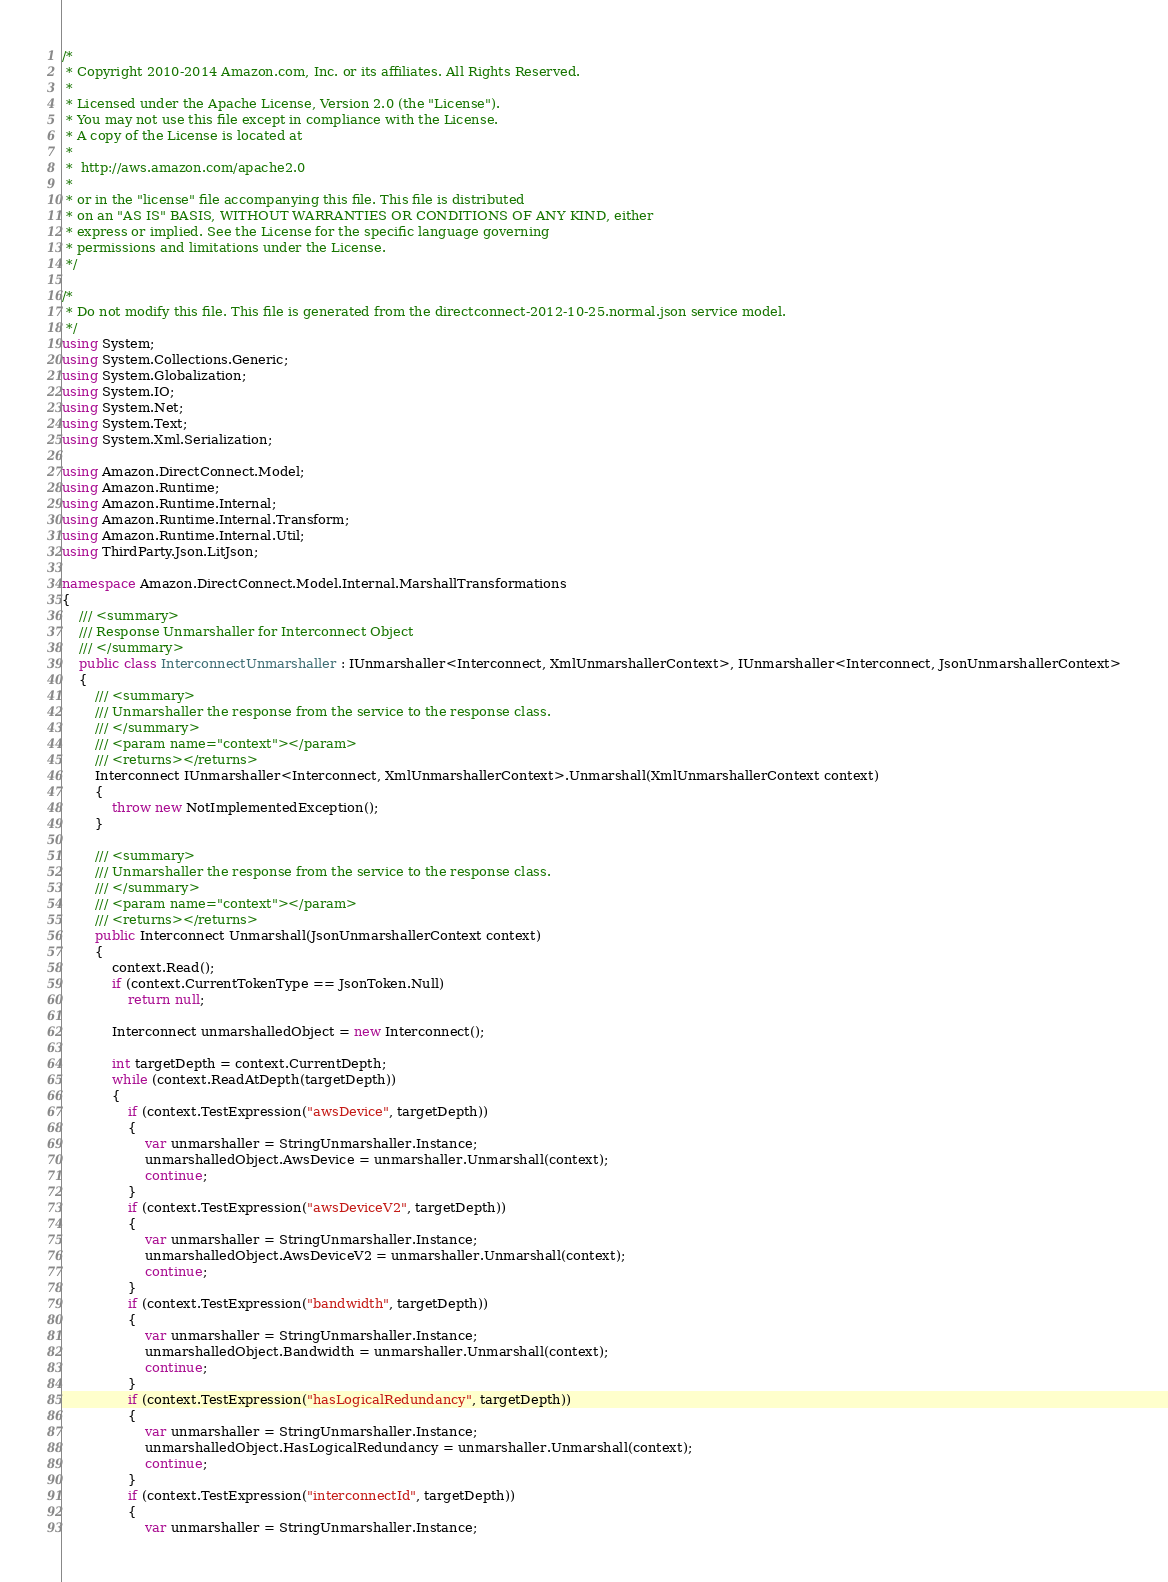Convert code to text. <code><loc_0><loc_0><loc_500><loc_500><_C#_>/*
 * Copyright 2010-2014 Amazon.com, Inc. or its affiliates. All Rights Reserved.
 * 
 * Licensed under the Apache License, Version 2.0 (the "License").
 * You may not use this file except in compliance with the License.
 * A copy of the License is located at
 * 
 *  http://aws.amazon.com/apache2.0
 * 
 * or in the "license" file accompanying this file. This file is distributed
 * on an "AS IS" BASIS, WITHOUT WARRANTIES OR CONDITIONS OF ANY KIND, either
 * express or implied. See the License for the specific language governing
 * permissions and limitations under the License.
 */

/*
 * Do not modify this file. This file is generated from the directconnect-2012-10-25.normal.json service model.
 */
using System;
using System.Collections.Generic;
using System.Globalization;
using System.IO;
using System.Net;
using System.Text;
using System.Xml.Serialization;

using Amazon.DirectConnect.Model;
using Amazon.Runtime;
using Amazon.Runtime.Internal;
using Amazon.Runtime.Internal.Transform;
using Amazon.Runtime.Internal.Util;
using ThirdParty.Json.LitJson;

namespace Amazon.DirectConnect.Model.Internal.MarshallTransformations
{
    /// <summary>
    /// Response Unmarshaller for Interconnect Object
    /// </summary>  
    public class InterconnectUnmarshaller : IUnmarshaller<Interconnect, XmlUnmarshallerContext>, IUnmarshaller<Interconnect, JsonUnmarshallerContext>
    {
        /// <summary>
        /// Unmarshaller the response from the service to the response class.
        /// </summary>  
        /// <param name="context"></param>
        /// <returns></returns>
        Interconnect IUnmarshaller<Interconnect, XmlUnmarshallerContext>.Unmarshall(XmlUnmarshallerContext context)
        {
            throw new NotImplementedException();
        }

        /// <summary>
        /// Unmarshaller the response from the service to the response class.
        /// </summary>  
        /// <param name="context"></param>
        /// <returns></returns>
        public Interconnect Unmarshall(JsonUnmarshallerContext context)
        {
            context.Read();
            if (context.CurrentTokenType == JsonToken.Null) 
                return null;

            Interconnect unmarshalledObject = new Interconnect();
        
            int targetDepth = context.CurrentDepth;
            while (context.ReadAtDepth(targetDepth))
            {
                if (context.TestExpression("awsDevice", targetDepth))
                {
                    var unmarshaller = StringUnmarshaller.Instance;
                    unmarshalledObject.AwsDevice = unmarshaller.Unmarshall(context);
                    continue;
                }
                if (context.TestExpression("awsDeviceV2", targetDepth))
                {
                    var unmarshaller = StringUnmarshaller.Instance;
                    unmarshalledObject.AwsDeviceV2 = unmarshaller.Unmarshall(context);
                    continue;
                }
                if (context.TestExpression("bandwidth", targetDepth))
                {
                    var unmarshaller = StringUnmarshaller.Instance;
                    unmarshalledObject.Bandwidth = unmarshaller.Unmarshall(context);
                    continue;
                }
                if (context.TestExpression("hasLogicalRedundancy", targetDepth))
                {
                    var unmarshaller = StringUnmarshaller.Instance;
                    unmarshalledObject.HasLogicalRedundancy = unmarshaller.Unmarshall(context);
                    continue;
                }
                if (context.TestExpression("interconnectId", targetDepth))
                {
                    var unmarshaller = StringUnmarshaller.Instance;</code> 